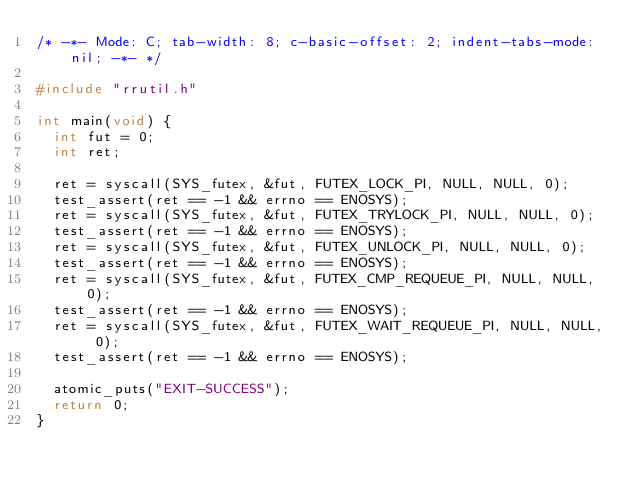Convert code to text. <code><loc_0><loc_0><loc_500><loc_500><_C_>/* -*- Mode: C; tab-width: 8; c-basic-offset: 2; indent-tabs-mode: nil; -*- */

#include "rrutil.h"

int main(void) {
  int fut = 0;
  int ret;

  ret = syscall(SYS_futex, &fut, FUTEX_LOCK_PI, NULL, NULL, 0);
  test_assert(ret == -1 && errno == ENOSYS);
  ret = syscall(SYS_futex, &fut, FUTEX_TRYLOCK_PI, NULL, NULL, 0);
  test_assert(ret == -1 && errno == ENOSYS);
  ret = syscall(SYS_futex, &fut, FUTEX_UNLOCK_PI, NULL, NULL, 0);
  test_assert(ret == -1 && errno == ENOSYS);
  ret = syscall(SYS_futex, &fut, FUTEX_CMP_REQUEUE_PI, NULL, NULL, 0);
  test_assert(ret == -1 && errno == ENOSYS);
  ret = syscall(SYS_futex, &fut, FUTEX_WAIT_REQUEUE_PI, NULL, NULL, 0);
  test_assert(ret == -1 && errno == ENOSYS);

  atomic_puts("EXIT-SUCCESS");
  return 0;
}
</code> 